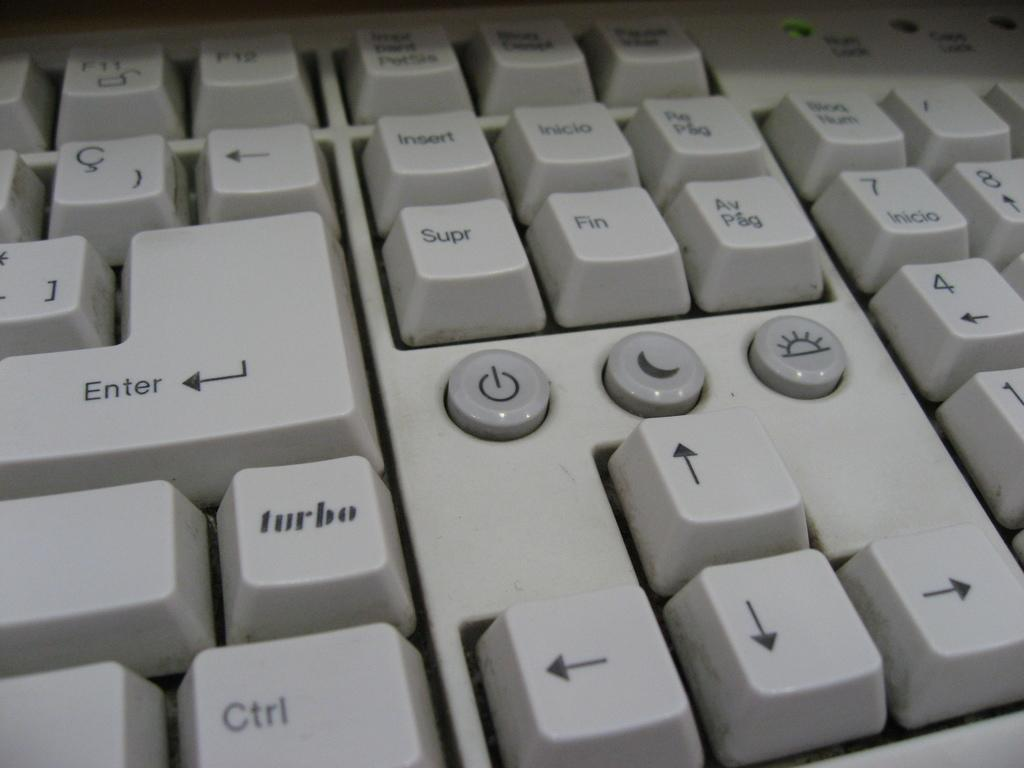<image>
Create a compact narrative representing the image presented. a close up of a white key board with a Turbo key 